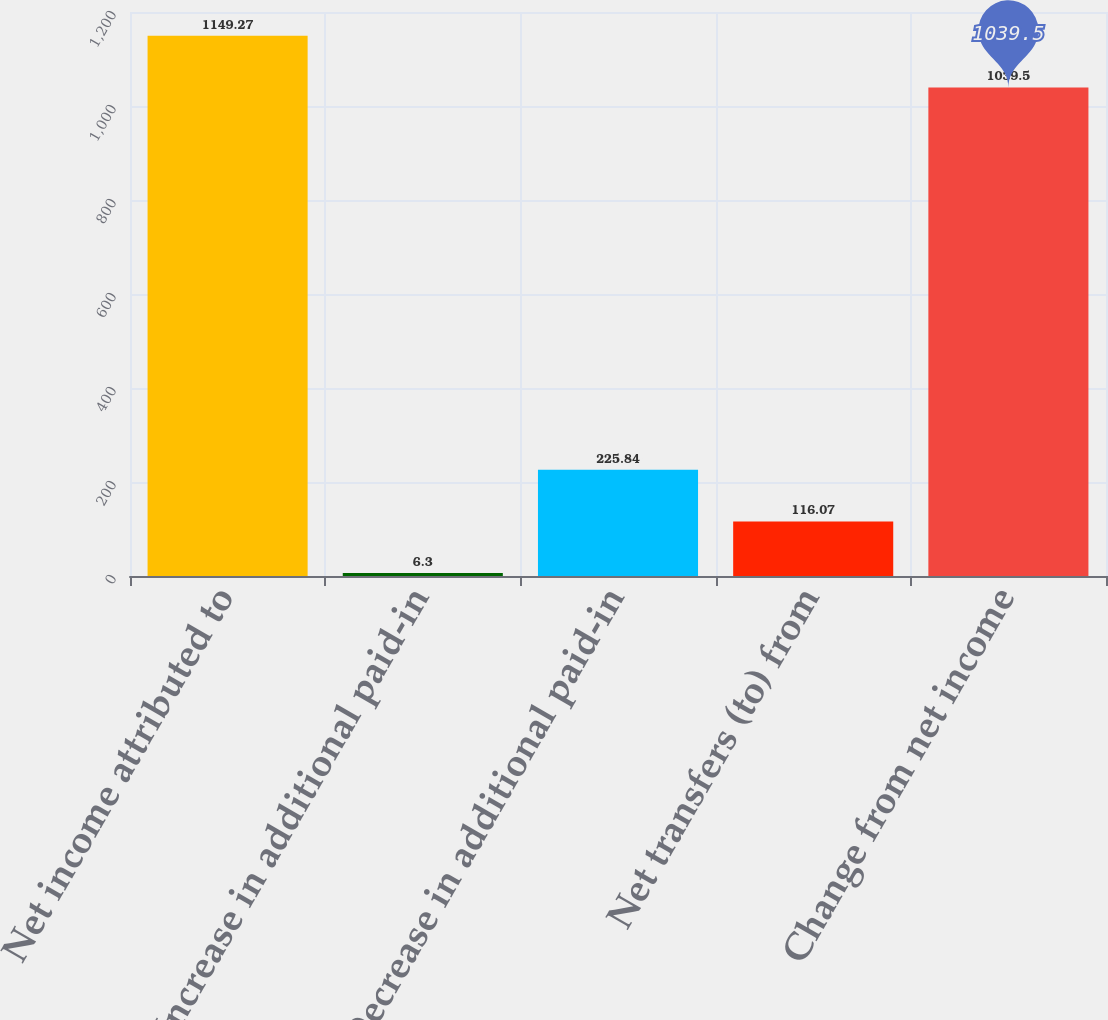Convert chart to OTSL. <chart><loc_0><loc_0><loc_500><loc_500><bar_chart><fcel>Net income attributed to<fcel>Increase in additional paid-in<fcel>Decrease in additional paid-in<fcel>Net transfers (to) from<fcel>Change from net income<nl><fcel>1149.27<fcel>6.3<fcel>225.84<fcel>116.07<fcel>1039.5<nl></chart> 